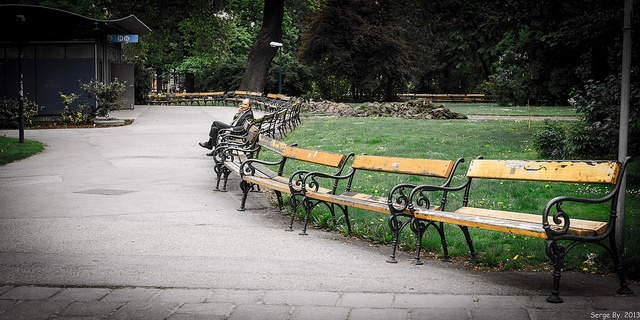Describe the objects in this image and their specific colors. I can see bench in black, darkgreen, gray, and tan tones, bench in black, green, gray, and darkgray tones, bench in black, darkgray, tan, and green tones, bench in black, gray, darkgray, and olive tones, and bench in black, darkgray, lightgray, and gray tones in this image. 